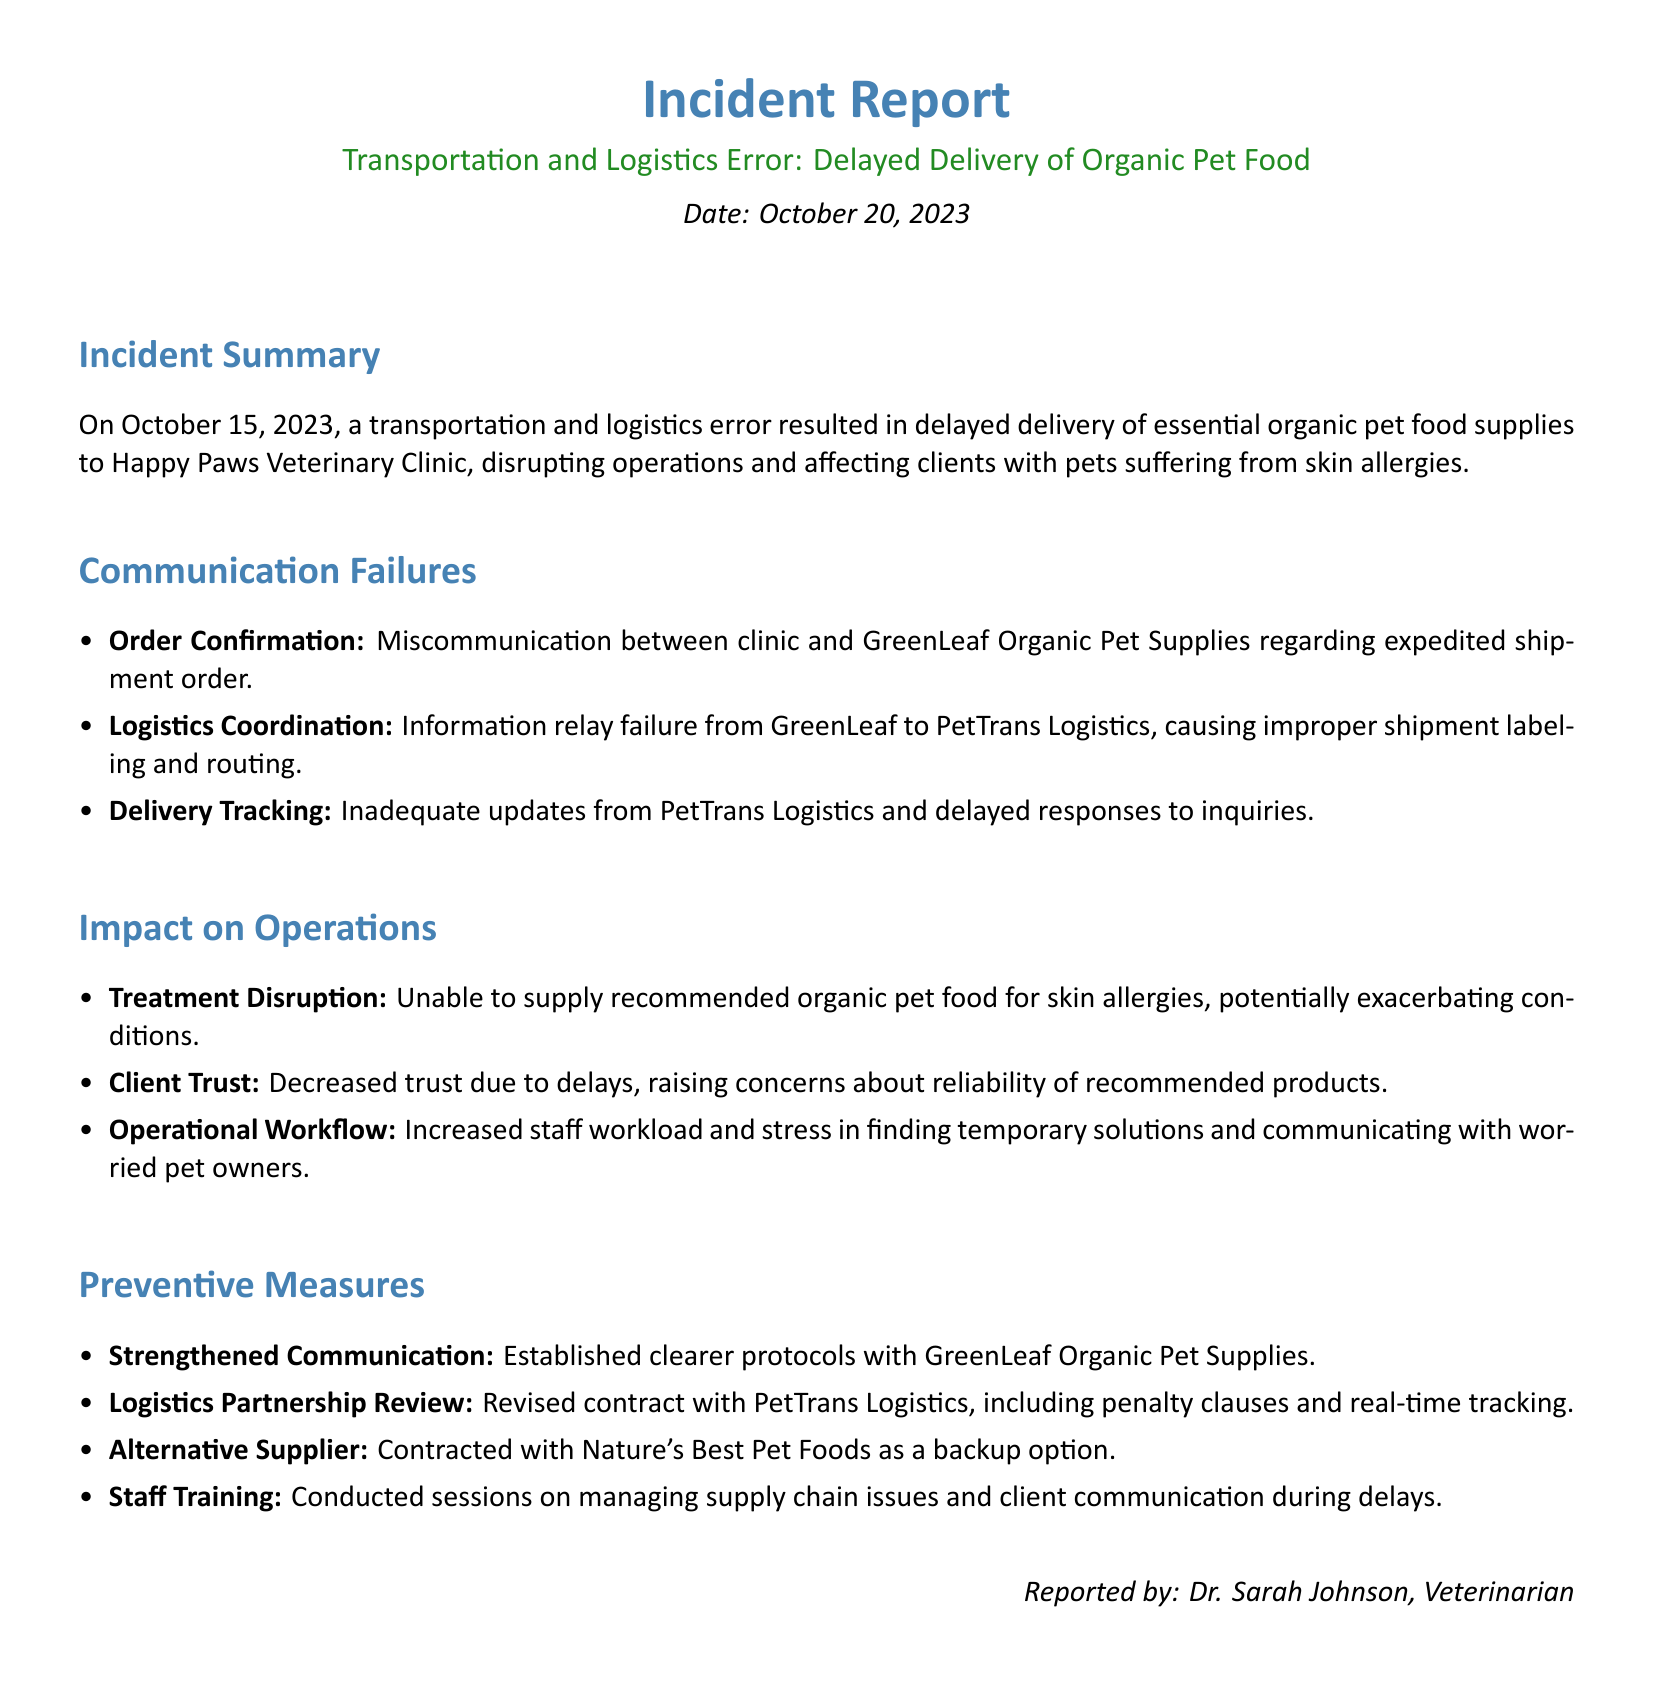What date did the incident occur? The incident occurred on October 15, 2023, as stated in the incident summary.
Answer: October 15, 2023 What is the name of the veterinary clinic affected? The affected clinic is explicitly mentioned in the document as Happy Paws Veterinary Clinic.
Answer: Happy Paws Veterinary Clinic What type of products were delayed? The report specifically refers to essential organic pet food supplies as the delayed products.
Answer: Organic pet food supplies What was the main cause of the communication failure? The main cause of the communication failure was miscommunication regarding the expedited shipment order.
Answer: Miscommunication Which company was contracted as a backup option? The document lists Nature's Best Pet Foods as the alternative supplier contracted for backup.
Answer: Nature's Best Pet Foods What impact did the delay have on client trust? The delay caused decreased trust among clients due to concerns about the reliability of the recommended products.
Answer: Decreased trust How many preventive measures were listed in the report? There are four preventive measures outlined in the section on preventive measures.
Answer: Four Who reported the incident? The incident was reported by Dr. Sarah Johnson, as mentioned at the end of the document.
Answer: Dr. Sarah Johnson 